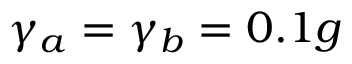<formula> <loc_0><loc_0><loc_500><loc_500>\gamma _ { a } = \gamma _ { b } = 0 . 1 g</formula> 